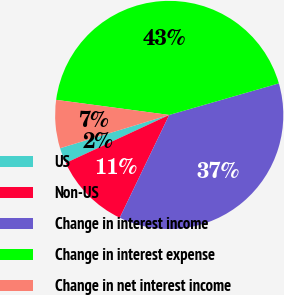Convert chart to OTSL. <chart><loc_0><loc_0><loc_500><loc_500><pie_chart><fcel>US<fcel>Non-US<fcel>Change in interest income<fcel>Change in interest expense<fcel>Change in net interest income<nl><fcel>2.21%<fcel>10.94%<fcel>36.6%<fcel>43.42%<fcel>6.82%<nl></chart> 